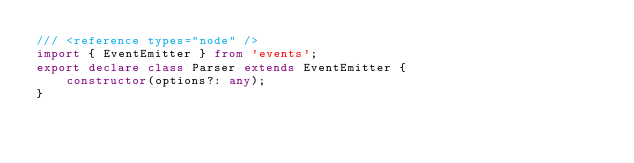Convert code to text. <code><loc_0><loc_0><loc_500><loc_500><_TypeScript_>/// <reference types="node" />
import { EventEmitter } from 'events';
export declare class Parser extends EventEmitter {
    constructor(options?: any);
}
</code> 